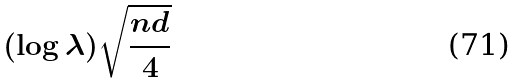<formula> <loc_0><loc_0><loc_500><loc_500>( \log \lambda ) \sqrt { \frac { n d } { 4 } }</formula> 